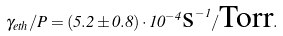<formula> <loc_0><loc_0><loc_500><loc_500>\gamma _ { e t h } / P = ( 5 . 2 \pm 0 . 8 ) \cdot 1 0 ^ { - 4 } { \text {s} } ^ { - 1 } / { \text {Torr} } .</formula> 